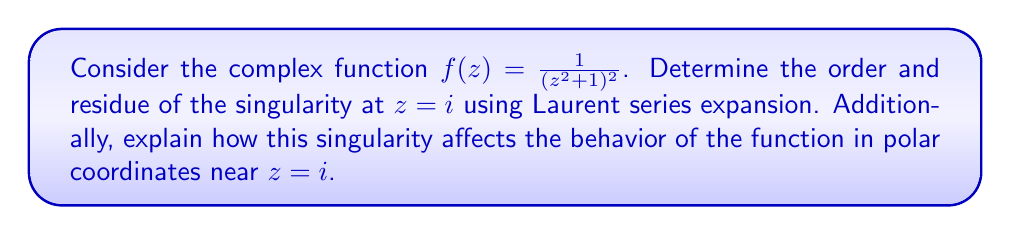Provide a solution to this math problem. To analyze the singularity at $z = i$, we'll follow these steps:

1) First, let's factor the denominator:
   $$(z^2 + 1)^2 = ((z-i)(z+i))^2$$

2) Now, we'll make a change of variable to center our Laurent series at $z = i$:
   Let $w = z - i$, so $z = w + i$

3) Substituting this into our function:
   $$f(z) = \frac{1}{((w+i)^2 + 1)^2} = \frac{1}{(w^2 + 2iw)^2} = \frac{1}{4w^2(w+2i)^2}$$

4) We can now expand this using the generalized binomial theorem:
   $$\frac{1}{4w^2(w+2i)^2} = \frac{1}{16w^2} \cdot \frac{1}{(1+\frac{w}{2i})^2}$$
   $$= \frac{1}{16w^2} \cdot (1 - \frac{w}{i} + \frac{3w^2}{4i^2} - \frac{5w^3}{8i^3} + ...)$$
   $$= \frac{1}{16w^2} + \frac{1}{16iw} - \frac{3}{64} + \frac{5i}{128w} + ...$$

5) The Laurent series has terms with negative powers of $w$, confirming that $z = i$ is indeed a singularity.

6) The highest negative power is $w^{-2}$, so the order of the singularity is 2. This makes it a pole of order 2.

7) The residue is the coefficient of the $w^{-1}$ term, which is $\frac{1}{16i}$.

In polar coordinates centered at $z = i$, we can write $w = re^{i\theta}$. Near $z = i$, $r$ is small, and the dominant term in the Laurent expansion is $\frac{1}{16w^2} = \frac{1}{16r^2e^{2i\theta}}$. This means:

a) The magnitude of $f(z)$ grows like $\frac{1}{r^2}$ as we approach $z = i$.
b) The argument of $f(z)$ rotates twice as fast as we circle around $z = i$.

This behavior is characteristic of a pole of order 2 in polar coordinates.
Answer: The singularity at $z = i$ is a pole of order 2. The residue at this pole is $\frac{1}{16i}$. 